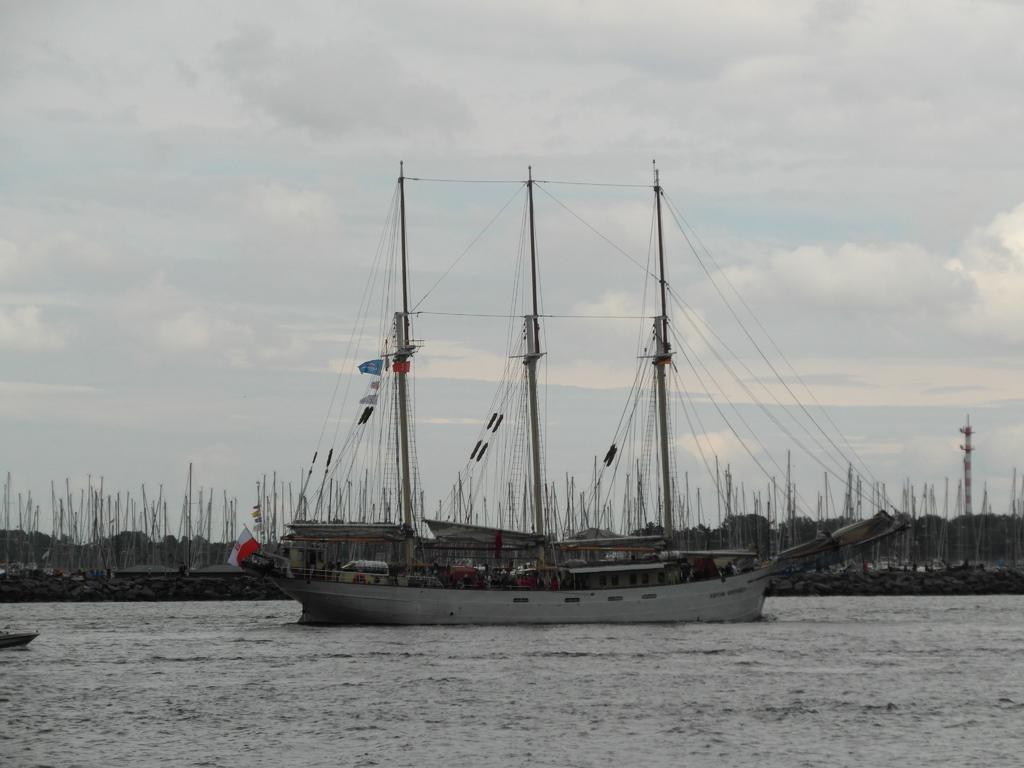Can you describe this image briefly? We can see ship above the water and we can see flag and poles with strings. In the background we can see poles, trees and sky with clouds. 